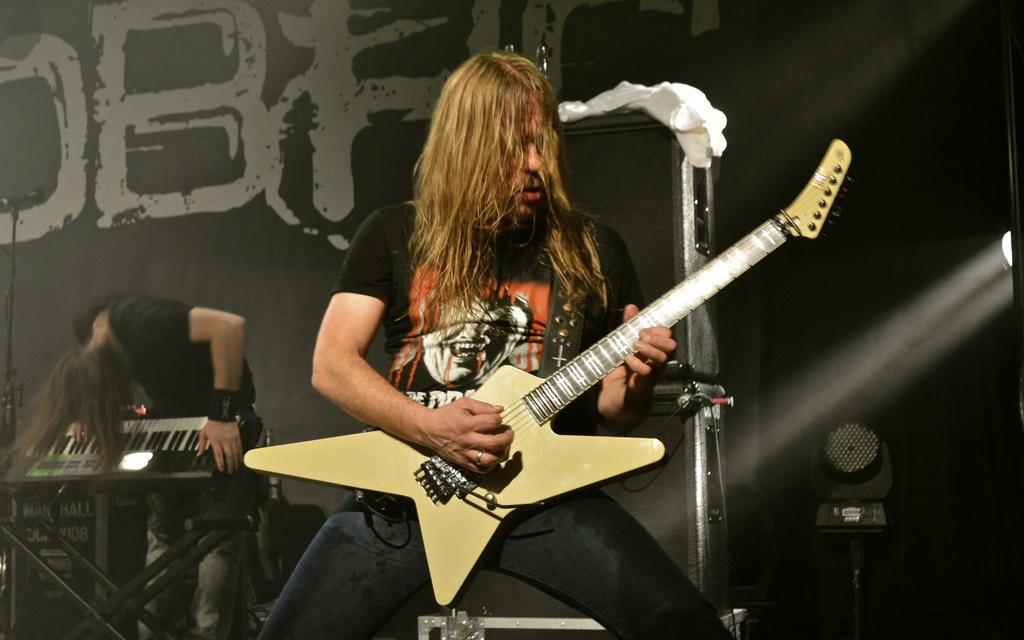In one or two sentences, can you explain what this image depicts? In this image, there are a few people playing musical instruments. We can also see some objects like a microphone and a stand. In the background, we can see the wall with some text. 